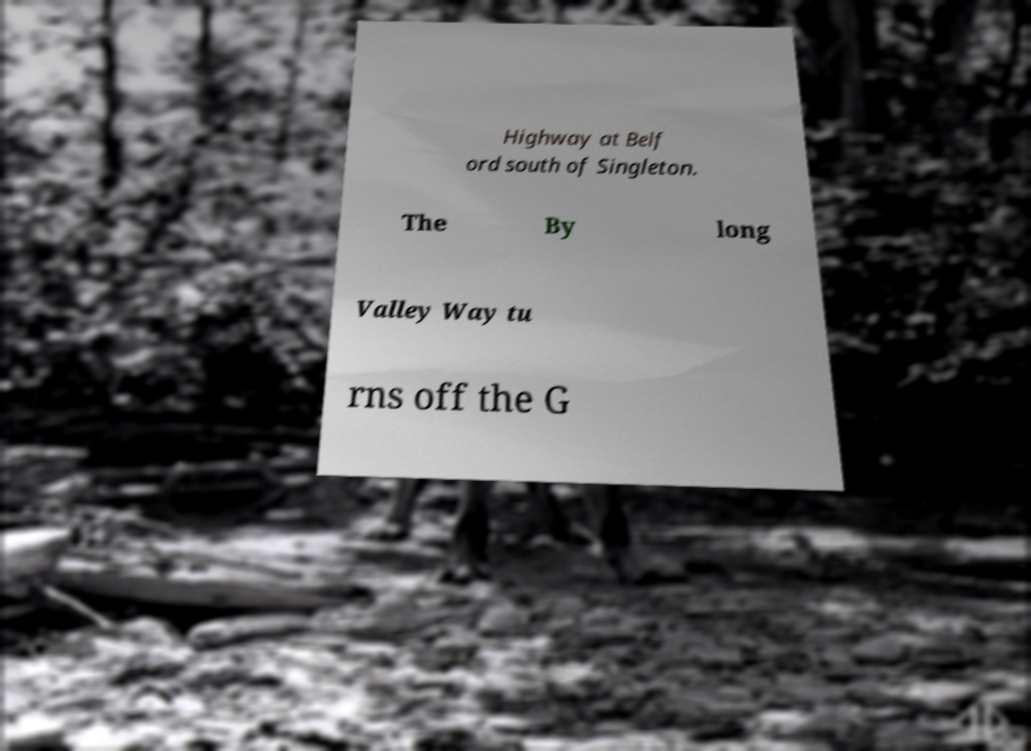What messages or text are displayed in this image? I need them in a readable, typed format. Highway at Belf ord south of Singleton. The By long Valley Way tu rns off the G 